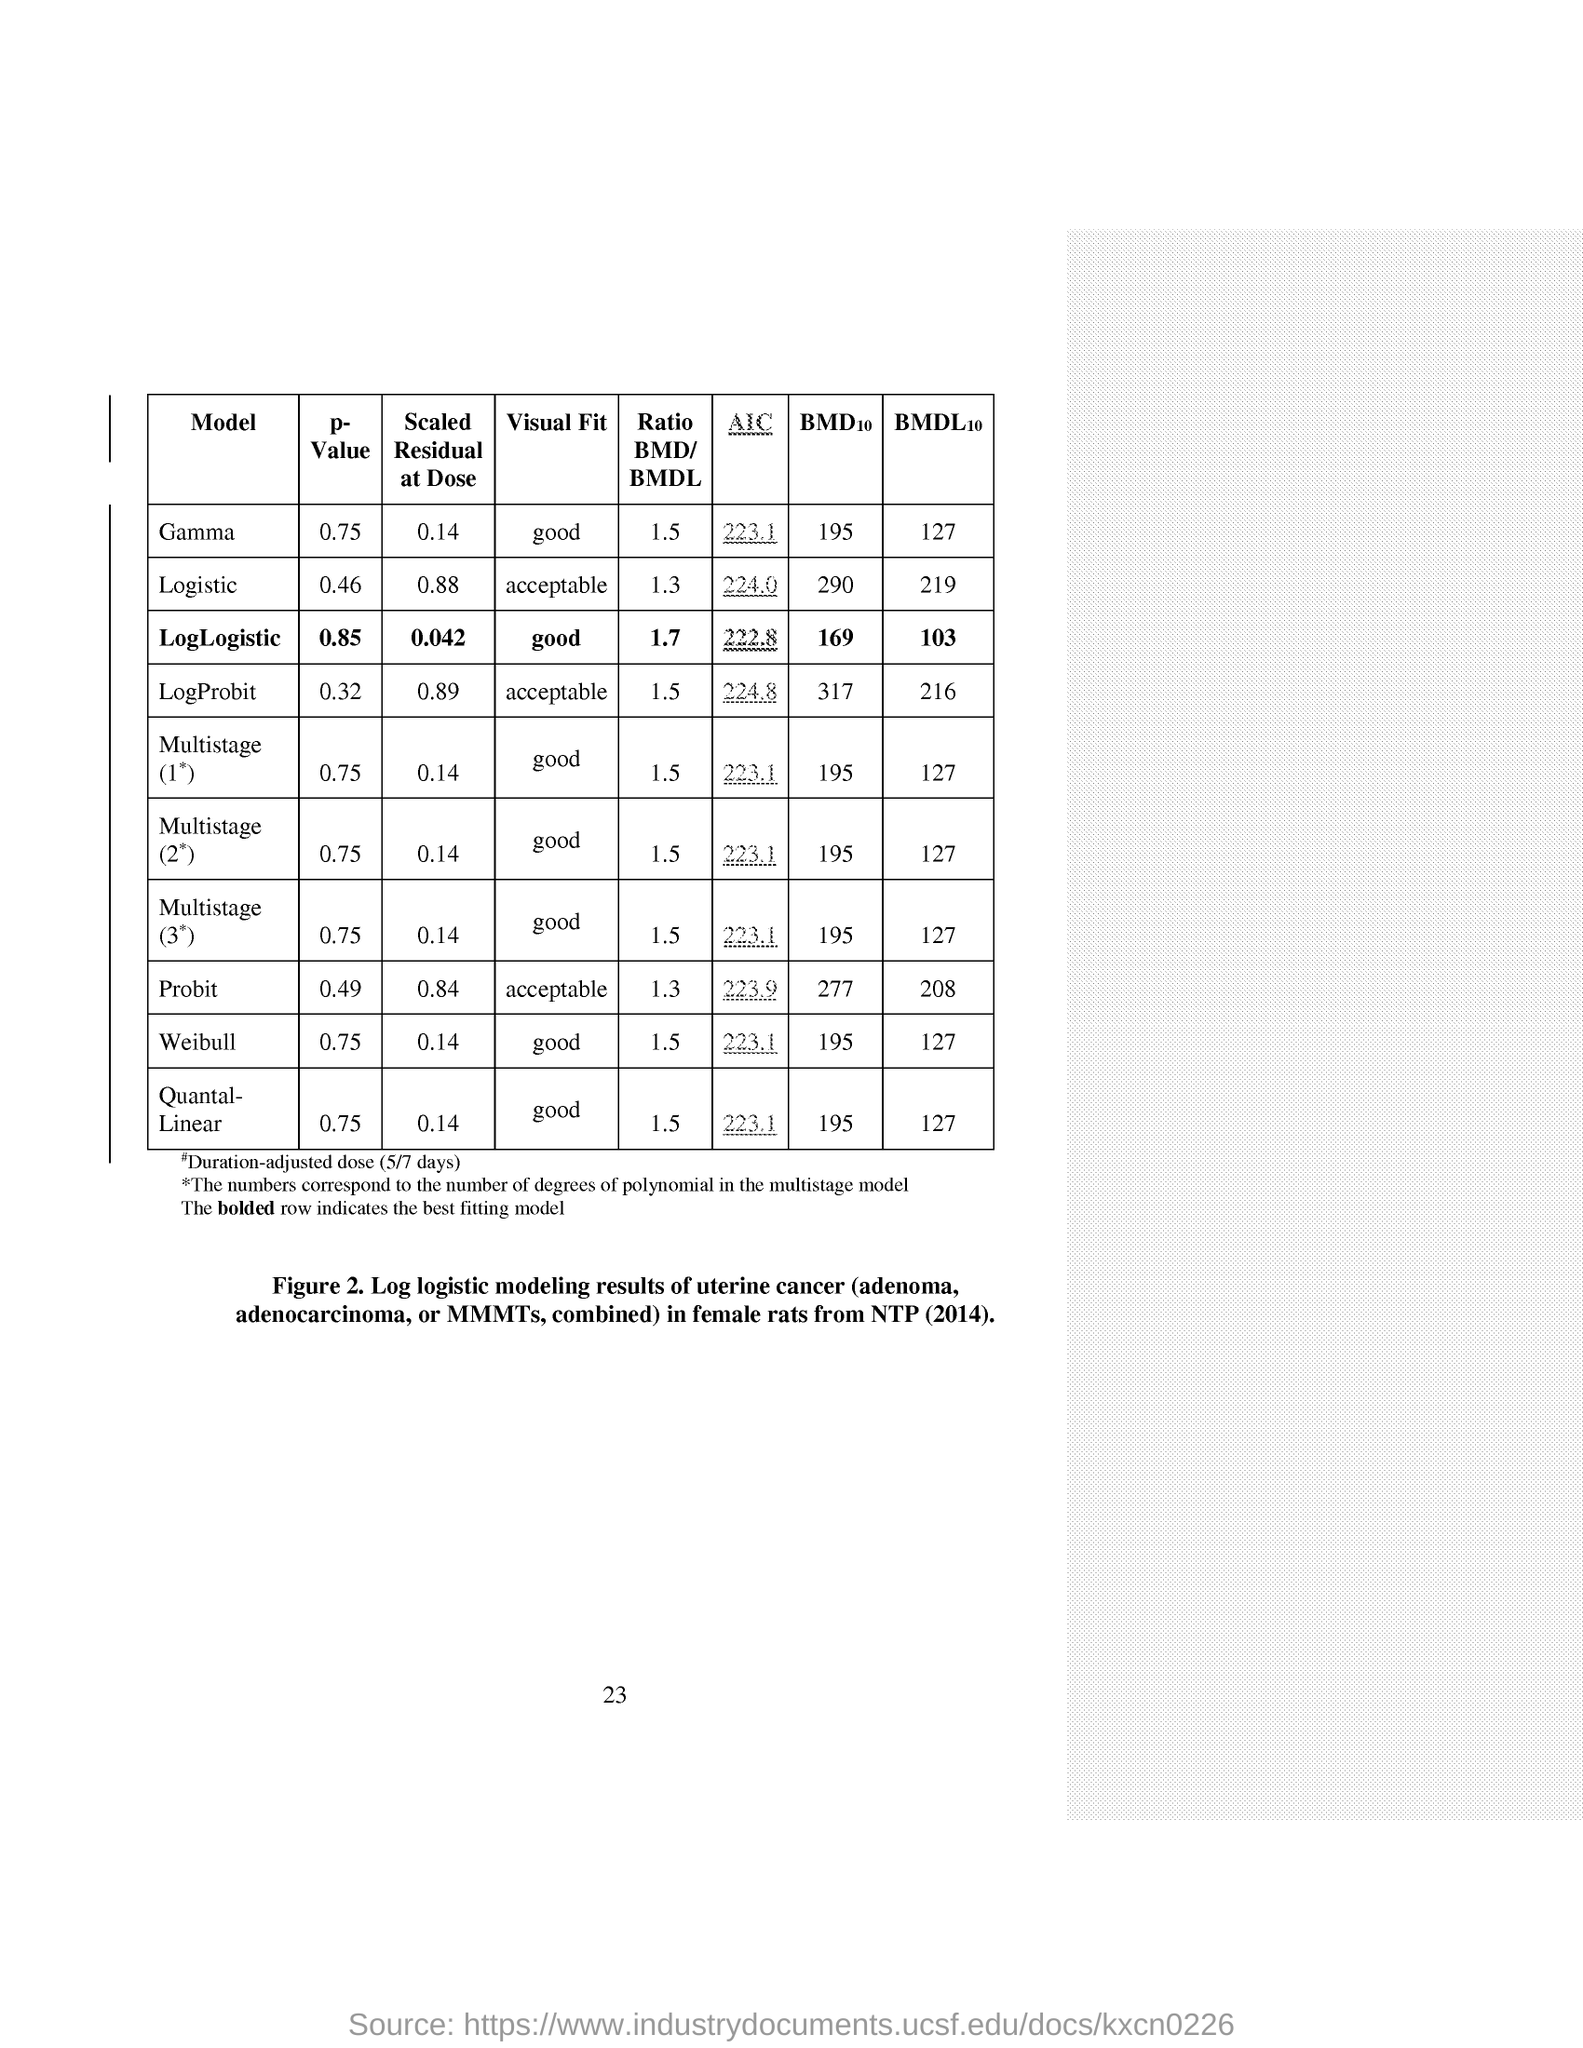Identify some key points in this picture. The ratio of bone mineral density (BMD) to the bone mineral density at the lower limit (BMDL) for multistage (stage 1) 1.5 is... The p-value of the Gamma distribution is 0.75. The visual fit of logistic is acceptable. The scaled residual at dose for the log-logistic model is 0.042… The AIC (Akaike Information Criterion) of the Weibull distribution is 223.1. 